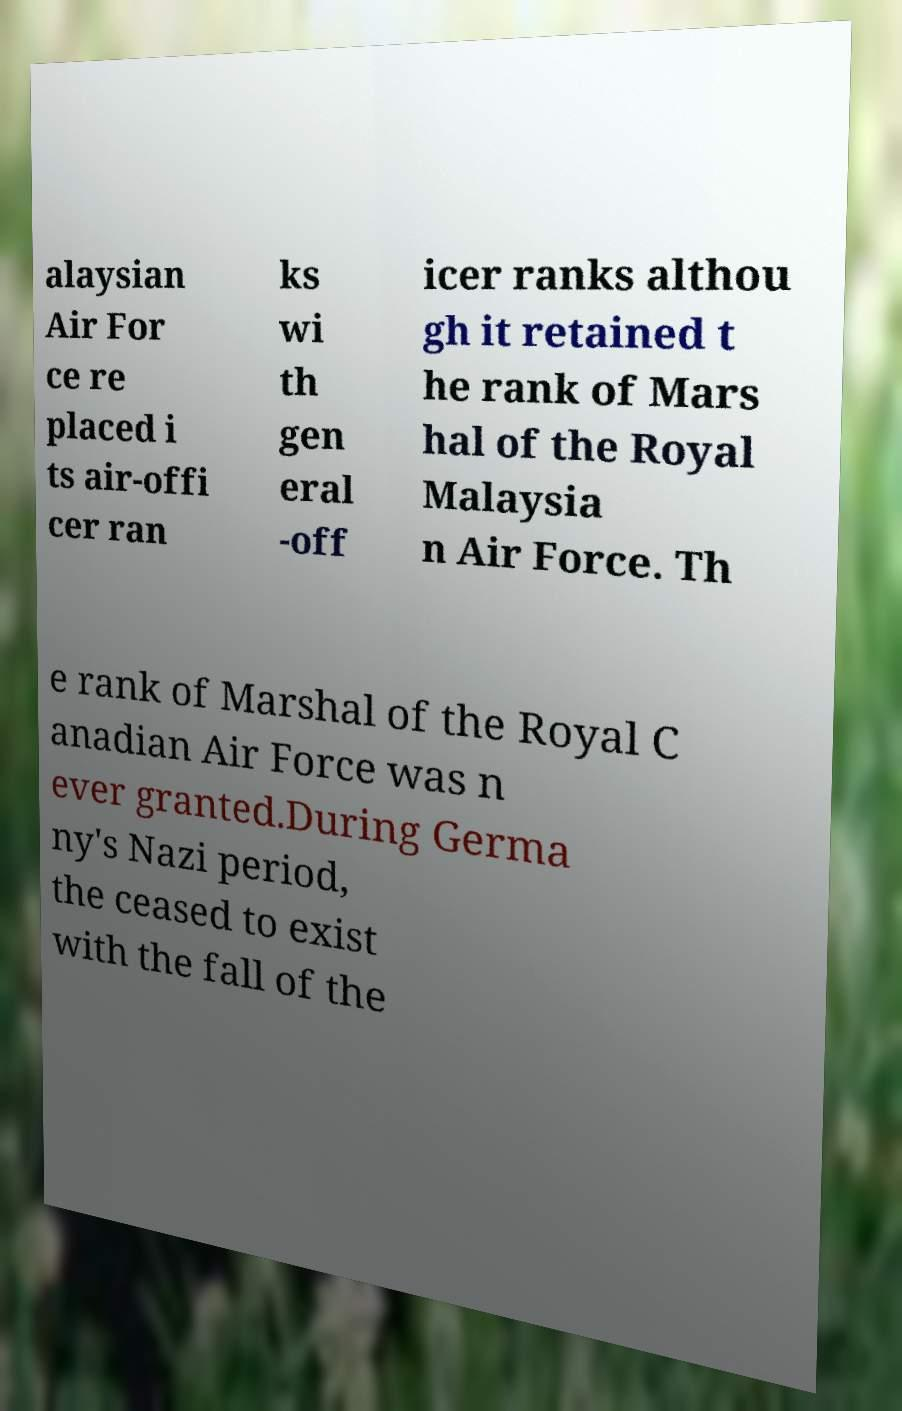Please read and relay the text visible in this image. What does it say? alaysian Air For ce re placed i ts air-offi cer ran ks wi th gen eral -off icer ranks althou gh it retained t he rank of Mars hal of the Royal Malaysia n Air Force. Th e rank of Marshal of the Royal C anadian Air Force was n ever granted.During Germa ny's Nazi period, the ceased to exist with the fall of the 